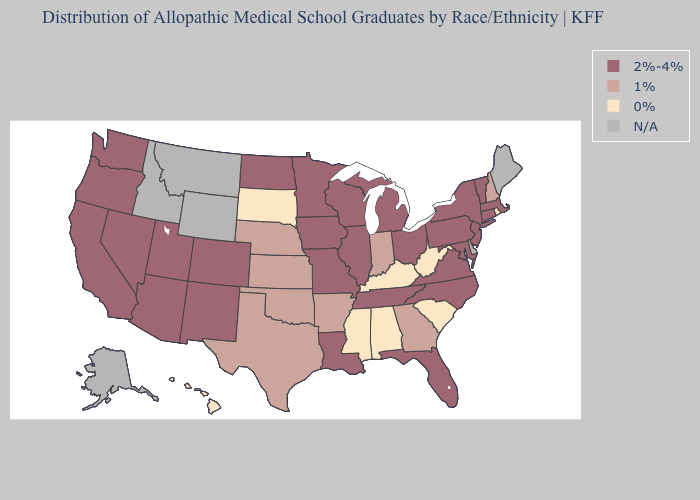How many symbols are there in the legend?
Concise answer only. 4. Does South Dakota have the lowest value in the USA?
Concise answer only. Yes. Which states hav the highest value in the South?
Be succinct. Florida, Louisiana, Maryland, North Carolina, Tennessee, Virginia. What is the value of Indiana?
Answer briefly. 1%. Does Kentucky have the highest value in the South?
Keep it brief. No. Which states have the lowest value in the MidWest?
Concise answer only. South Dakota. Name the states that have a value in the range 0%?
Short answer required. Alabama, Hawaii, Kentucky, Mississippi, Rhode Island, South Carolina, South Dakota, West Virginia. What is the value of Montana?
Answer briefly. N/A. Among the states that border Missouri , which have the highest value?
Short answer required. Illinois, Iowa, Tennessee. Is the legend a continuous bar?
Be succinct. No. Does the first symbol in the legend represent the smallest category?
Keep it brief. No. Is the legend a continuous bar?
Write a very short answer. No. Does Arizona have the highest value in the West?
Be succinct. Yes. What is the highest value in the USA?
Keep it brief. 2%-4%. 